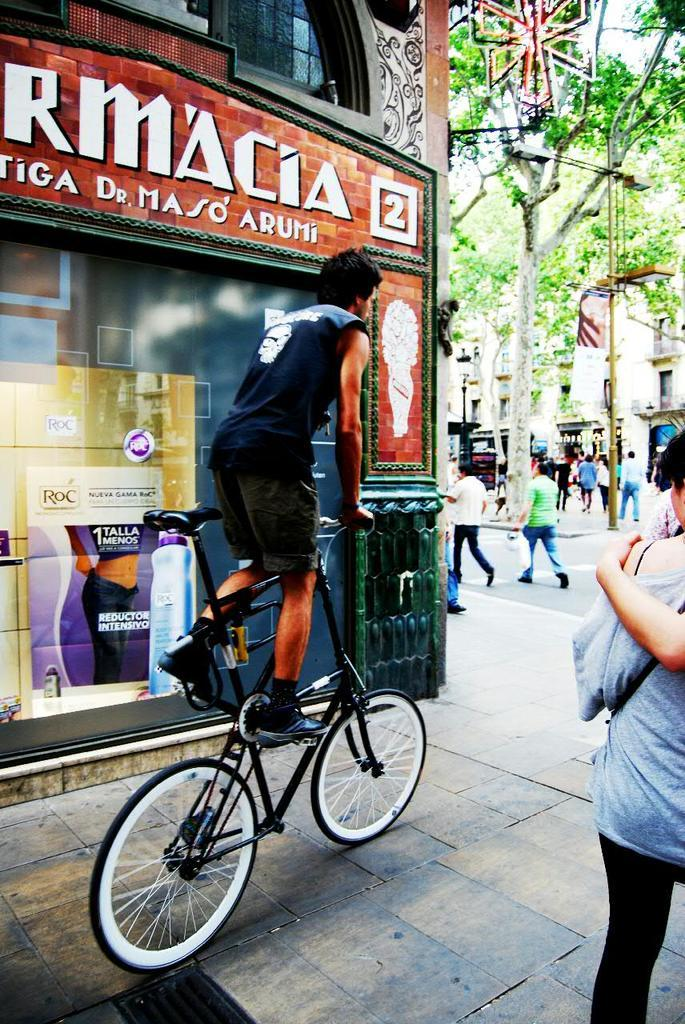What are the people in the image doing? There is a group of people walking on the road. What activity is the man in front of the shop engaged in? The man is doing a bicycle in front of a shop. What type of wine is the man holding while doing a bicycle in the image? There is no wine present in the image; the man is doing a bicycle in front of a shop. Is the man holding a gun while doing a bicycle in the image? There is no gun present in the image; the man is doing a bicycle in front of a shop. 